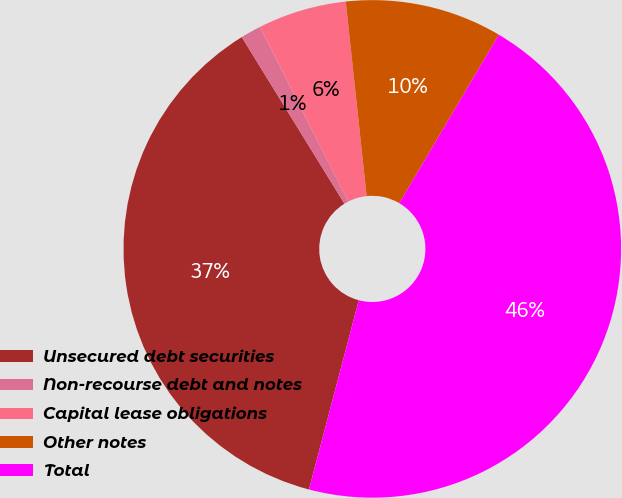Convert chart to OTSL. <chart><loc_0><loc_0><loc_500><loc_500><pie_chart><fcel>Unsecured debt securities<fcel>Non-recourse debt and notes<fcel>Capital lease obligations<fcel>Other notes<fcel>Total<nl><fcel>37.11%<fcel>1.33%<fcel>5.76%<fcel>10.19%<fcel>45.61%<nl></chart> 